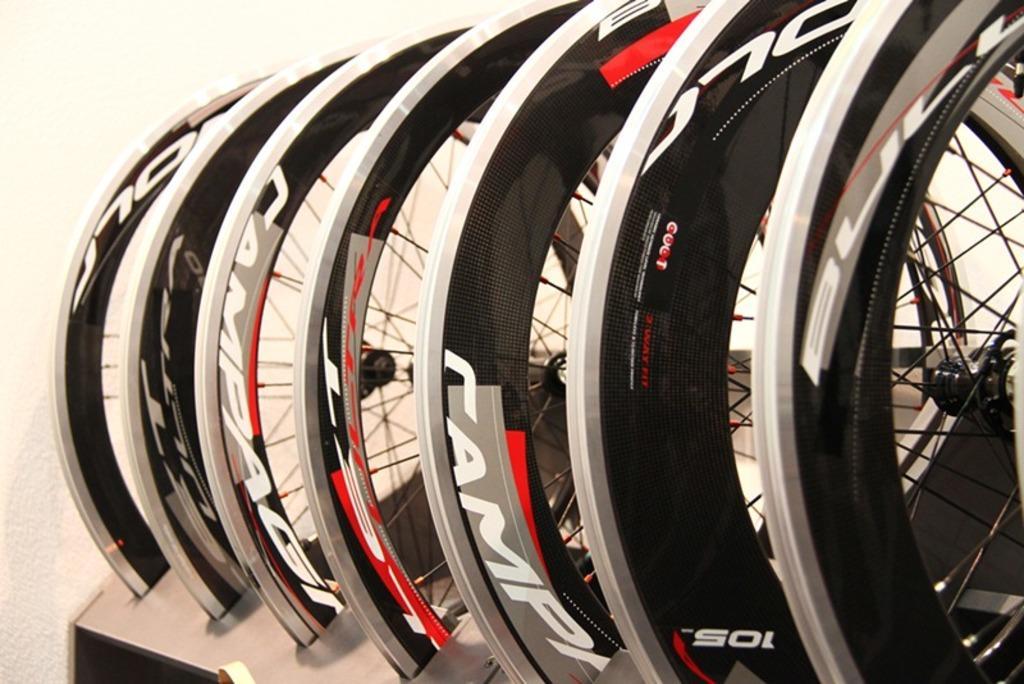Can you describe this image briefly? In this image we can see the cycle wheels in some stand. We can also see the wall in the background. 